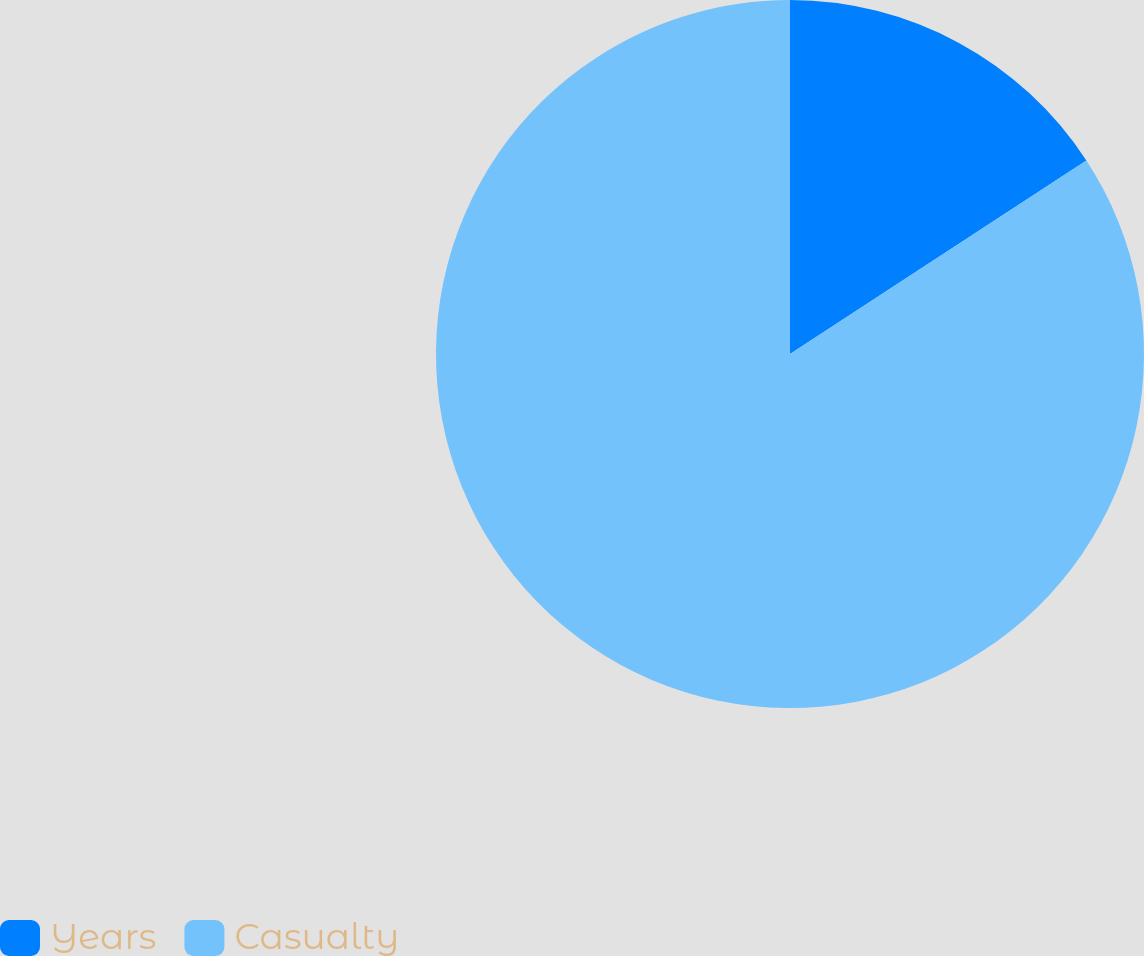Convert chart. <chart><loc_0><loc_0><loc_500><loc_500><pie_chart><fcel>Years<fcel>Casualty<nl><fcel>15.79%<fcel>84.21%<nl></chart> 